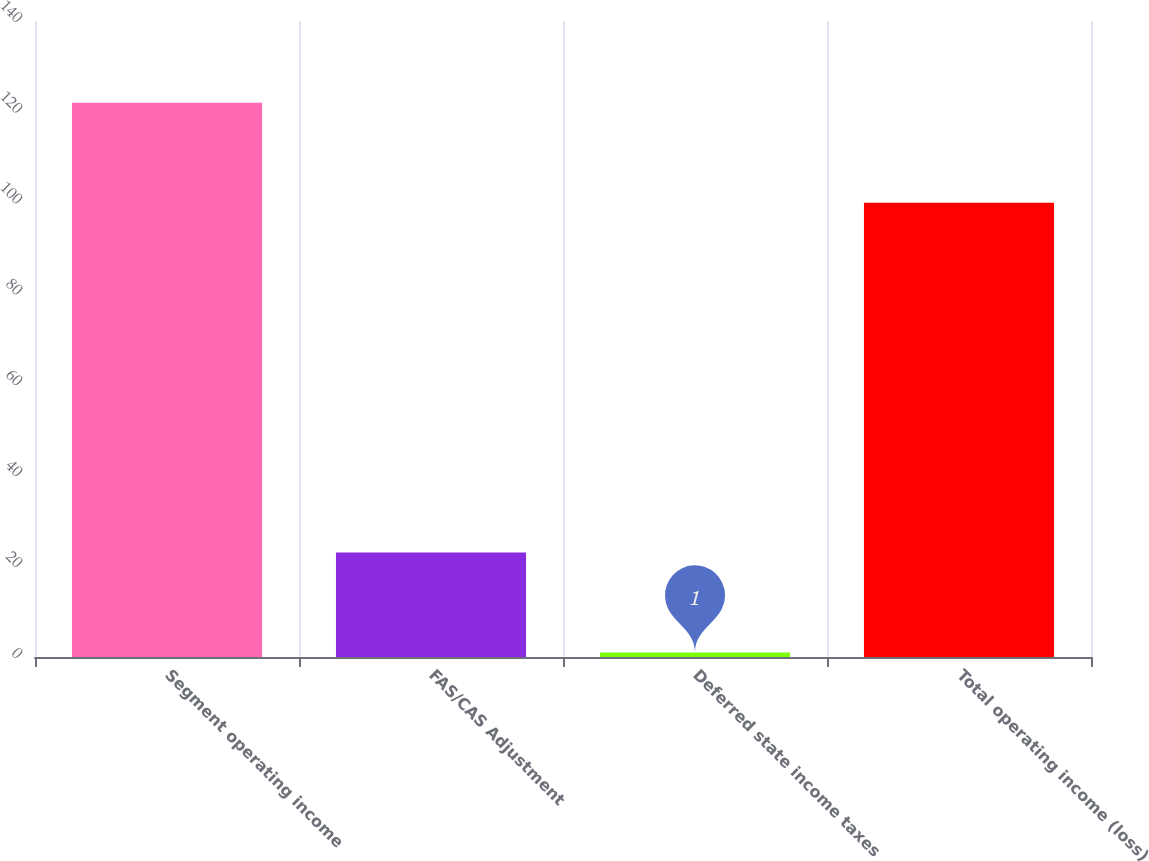Convert chart. <chart><loc_0><loc_0><loc_500><loc_500><bar_chart><fcel>Segment operating income<fcel>FAS/CAS Adjustment<fcel>Deferred state income taxes<fcel>Total operating income (loss)<nl><fcel>122<fcel>23<fcel>1<fcel>100<nl></chart> 